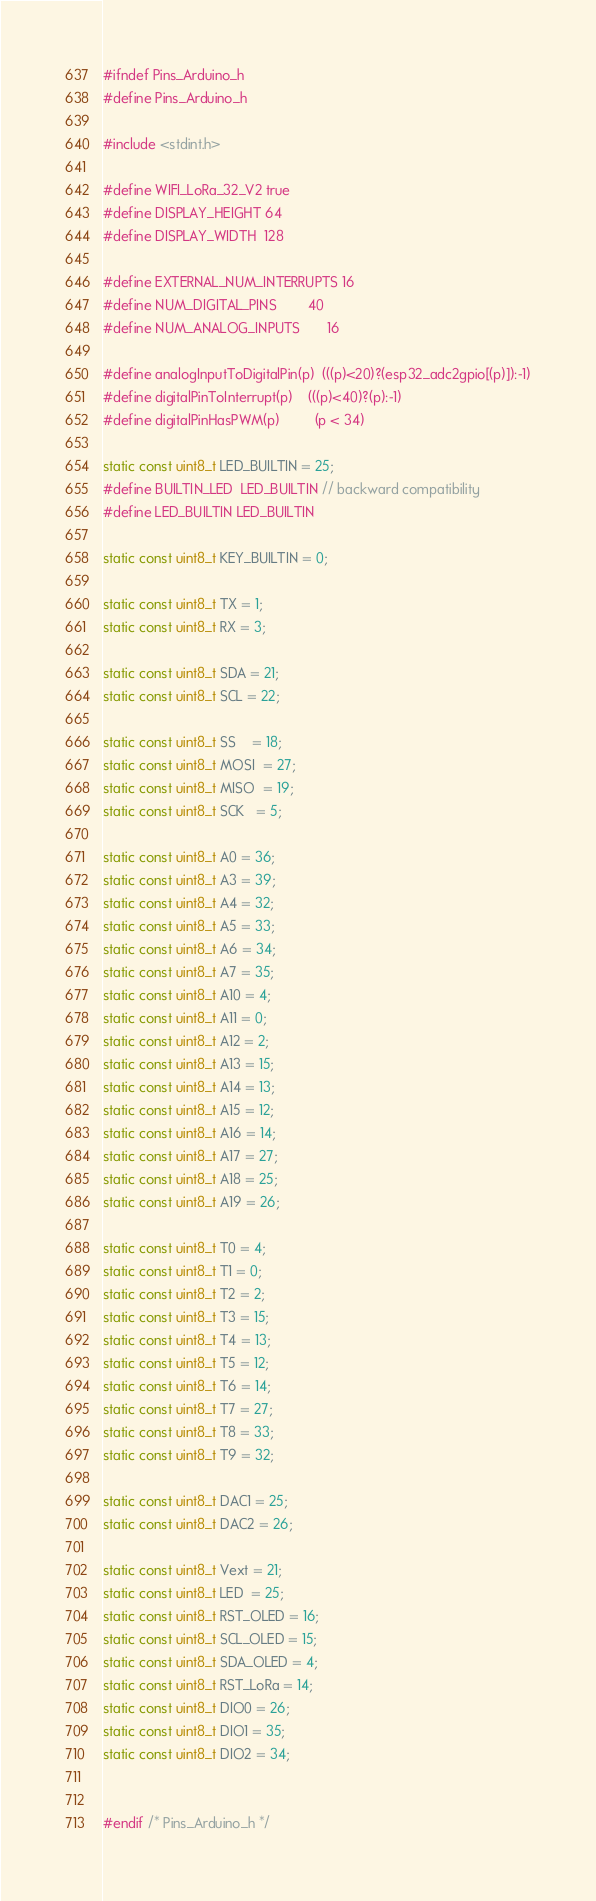<code> <loc_0><loc_0><loc_500><loc_500><_C_>#ifndef Pins_Arduino_h
#define Pins_Arduino_h

#include <stdint.h>

#define WIFI_LoRa_32_V2 true
#define DISPLAY_HEIGHT 64
#define DISPLAY_WIDTH  128

#define EXTERNAL_NUM_INTERRUPTS 16
#define NUM_DIGITAL_PINS        40
#define NUM_ANALOG_INPUTS       16

#define analogInputToDigitalPin(p)  (((p)<20)?(esp32_adc2gpio[(p)]):-1)
#define digitalPinToInterrupt(p)    (((p)<40)?(p):-1)
#define digitalPinHasPWM(p)         (p < 34)

static const uint8_t LED_BUILTIN = 25;
#define BUILTIN_LED  LED_BUILTIN // backward compatibility
#define LED_BUILTIN LED_BUILTIN

static const uint8_t KEY_BUILTIN = 0;

static const uint8_t TX = 1;
static const uint8_t RX = 3;

static const uint8_t SDA = 21;
static const uint8_t SCL = 22;

static const uint8_t SS    = 18;
static const uint8_t MOSI  = 27;
static const uint8_t MISO  = 19;
static const uint8_t SCK   = 5;

static const uint8_t A0 = 36;
static const uint8_t A3 = 39;
static const uint8_t A4 = 32;
static const uint8_t A5 = 33;
static const uint8_t A6 = 34;
static const uint8_t A7 = 35;
static const uint8_t A10 = 4;
static const uint8_t A11 = 0;
static const uint8_t A12 = 2;
static const uint8_t A13 = 15;
static const uint8_t A14 = 13;
static const uint8_t A15 = 12;
static const uint8_t A16 = 14;
static const uint8_t A17 = 27;
static const uint8_t A18 = 25;
static const uint8_t A19 = 26;

static const uint8_t T0 = 4;
static const uint8_t T1 = 0;
static const uint8_t T2 = 2;
static const uint8_t T3 = 15;
static const uint8_t T4 = 13;
static const uint8_t T5 = 12;
static const uint8_t T6 = 14;
static const uint8_t T7 = 27;
static const uint8_t T8 = 33;
static const uint8_t T9 = 32;

static const uint8_t DAC1 = 25;
static const uint8_t DAC2 = 26;

static const uint8_t Vext = 21;
static const uint8_t LED  = 25;
static const uint8_t RST_OLED = 16;
static const uint8_t SCL_OLED = 15;
static const uint8_t SDA_OLED = 4;
static const uint8_t RST_LoRa = 14;
static const uint8_t DIO0 = 26;
static const uint8_t DIO1 = 35;
static const uint8_t DIO2 = 34;


#endif /* Pins_Arduino_h */
</code> 